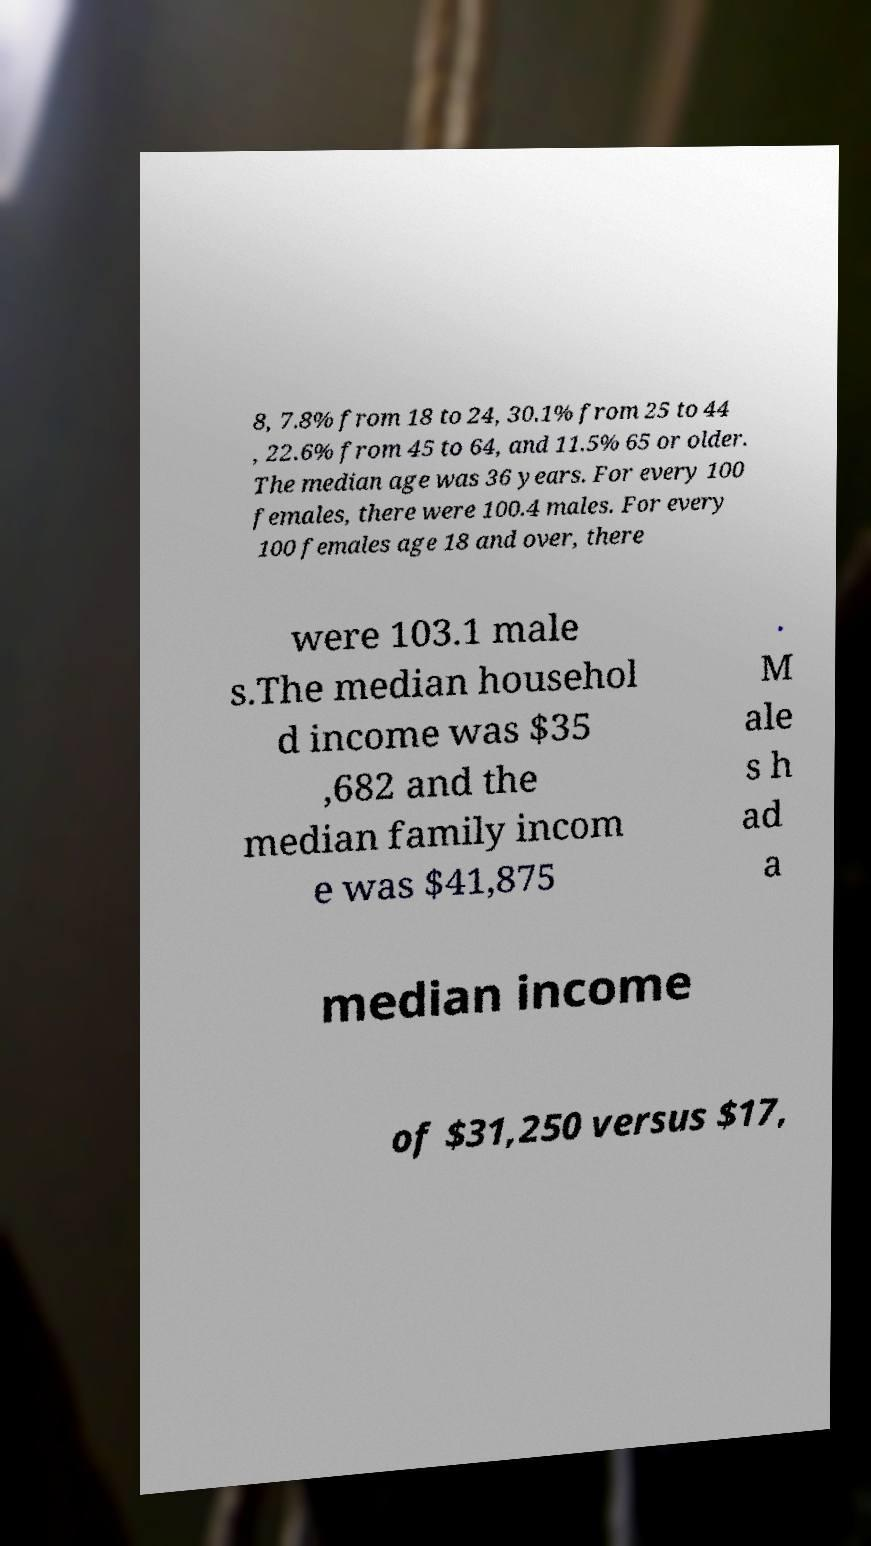What messages or text are displayed in this image? I need them in a readable, typed format. 8, 7.8% from 18 to 24, 30.1% from 25 to 44 , 22.6% from 45 to 64, and 11.5% 65 or older. The median age was 36 years. For every 100 females, there were 100.4 males. For every 100 females age 18 and over, there were 103.1 male s.The median househol d income was $35 ,682 and the median family incom e was $41,875 . M ale s h ad a median income of $31,250 versus $17, 